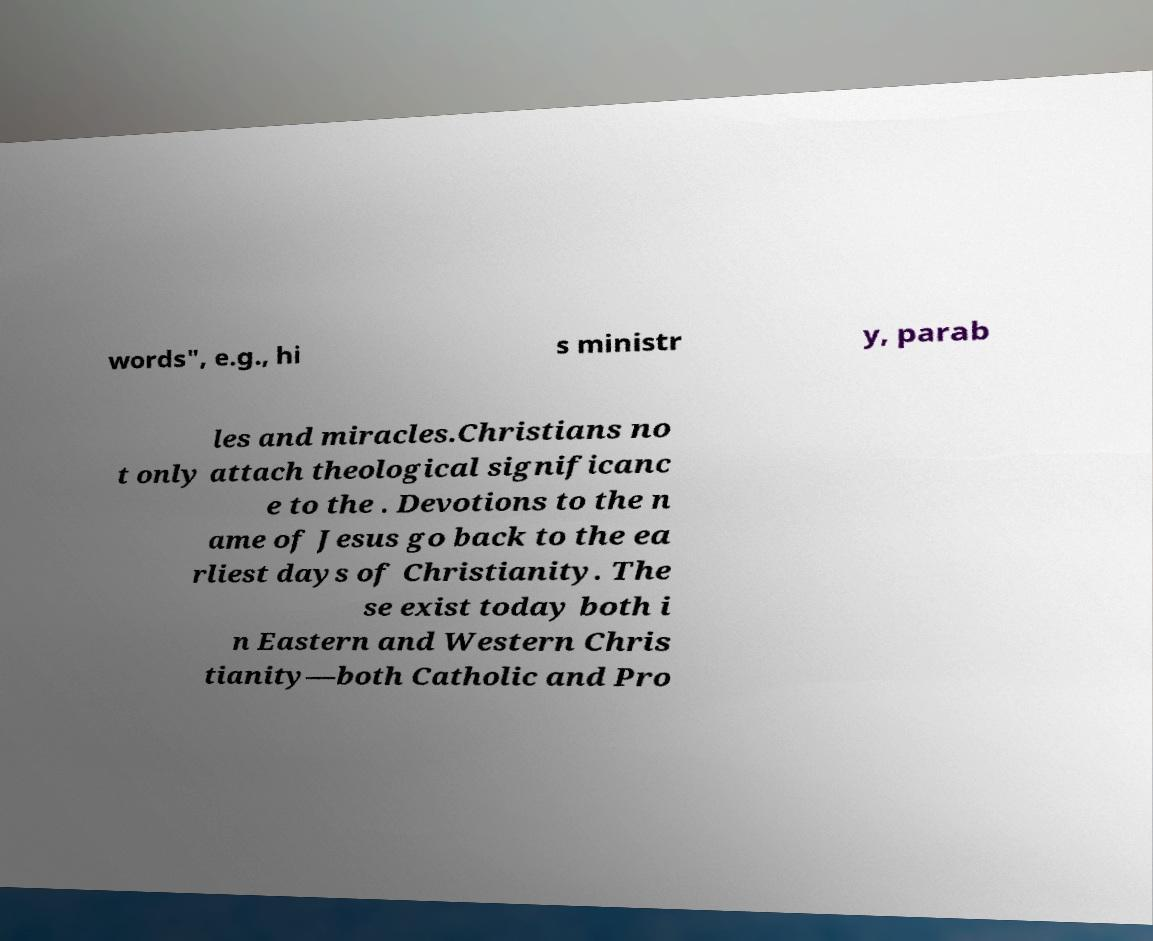Could you assist in decoding the text presented in this image and type it out clearly? words", e.g., hi s ministr y, parab les and miracles.Christians no t only attach theological significanc e to the . Devotions to the n ame of Jesus go back to the ea rliest days of Christianity. The se exist today both i n Eastern and Western Chris tianity—both Catholic and Pro 